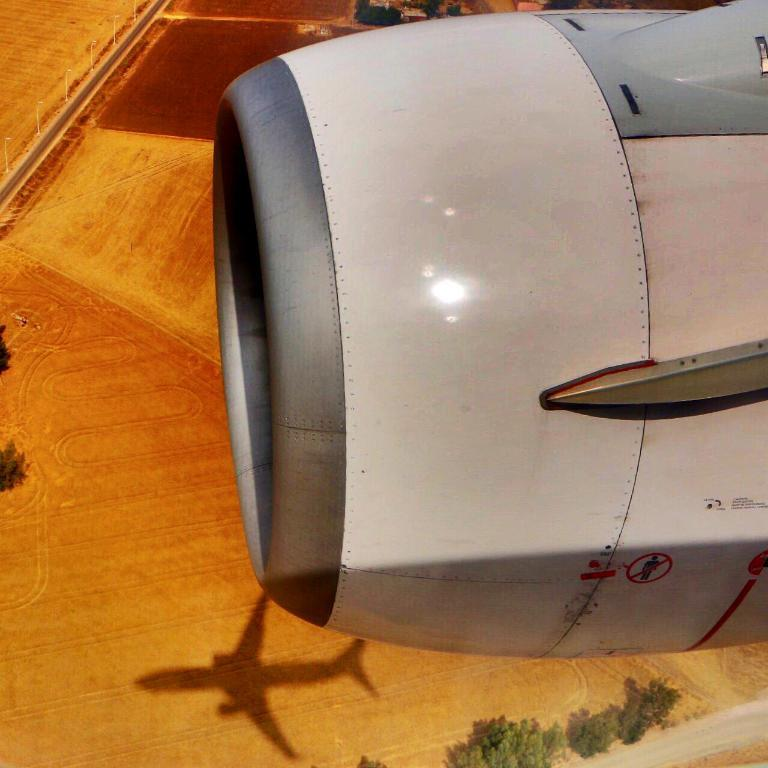What is the main subject in the foreground of the image? There is a plane turbine in the foreground of the image. Where is the plane turbine located in relation to the image? The plane turbine is on the right side of the image. What can be seen in the background of the image? There is ground, a road, poles, trees, and the shadow of a plane visible in the background of the image. How many horses are visible in the image? There are no horses present in the image. What type of scale is used to measure the size of the plane turbine in the image? There is no scale present in the image, and the size of the plane turbine cannot be measured from the image alone. 